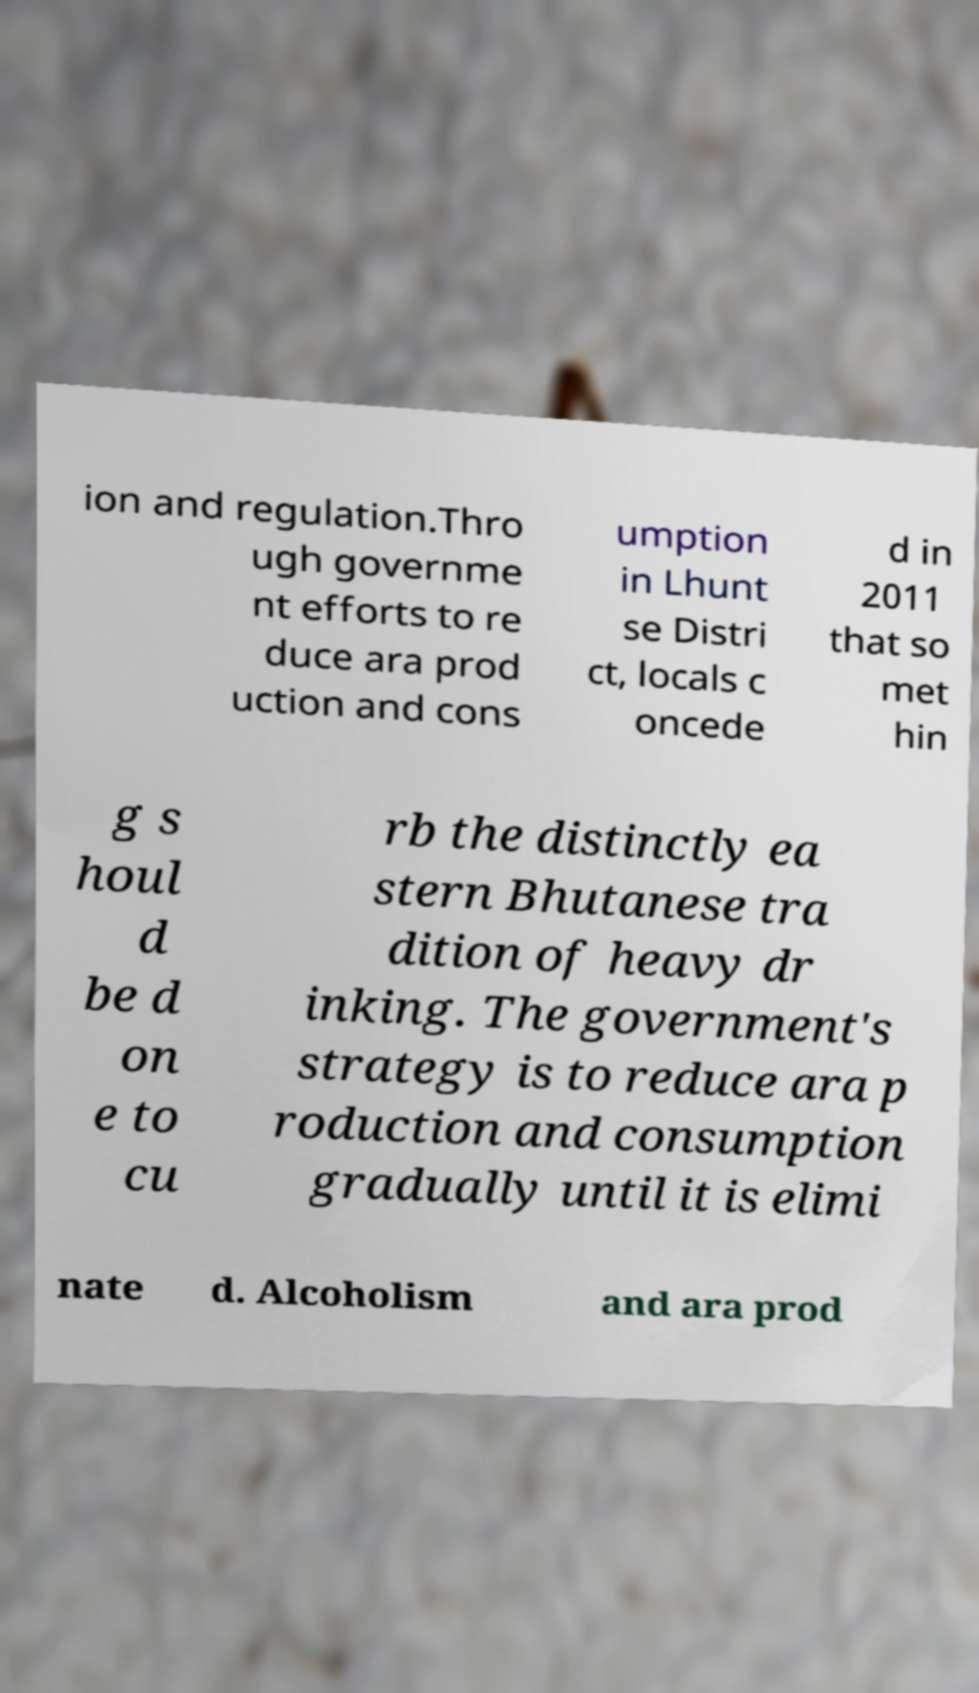There's text embedded in this image that I need extracted. Can you transcribe it verbatim? ion and regulation.Thro ugh governme nt efforts to re duce ara prod uction and cons umption in Lhunt se Distri ct, locals c oncede d in 2011 that so met hin g s houl d be d on e to cu rb the distinctly ea stern Bhutanese tra dition of heavy dr inking. The government's strategy is to reduce ara p roduction and consumption gradually until it is elimi nate d. Alcoholism and ara prod 